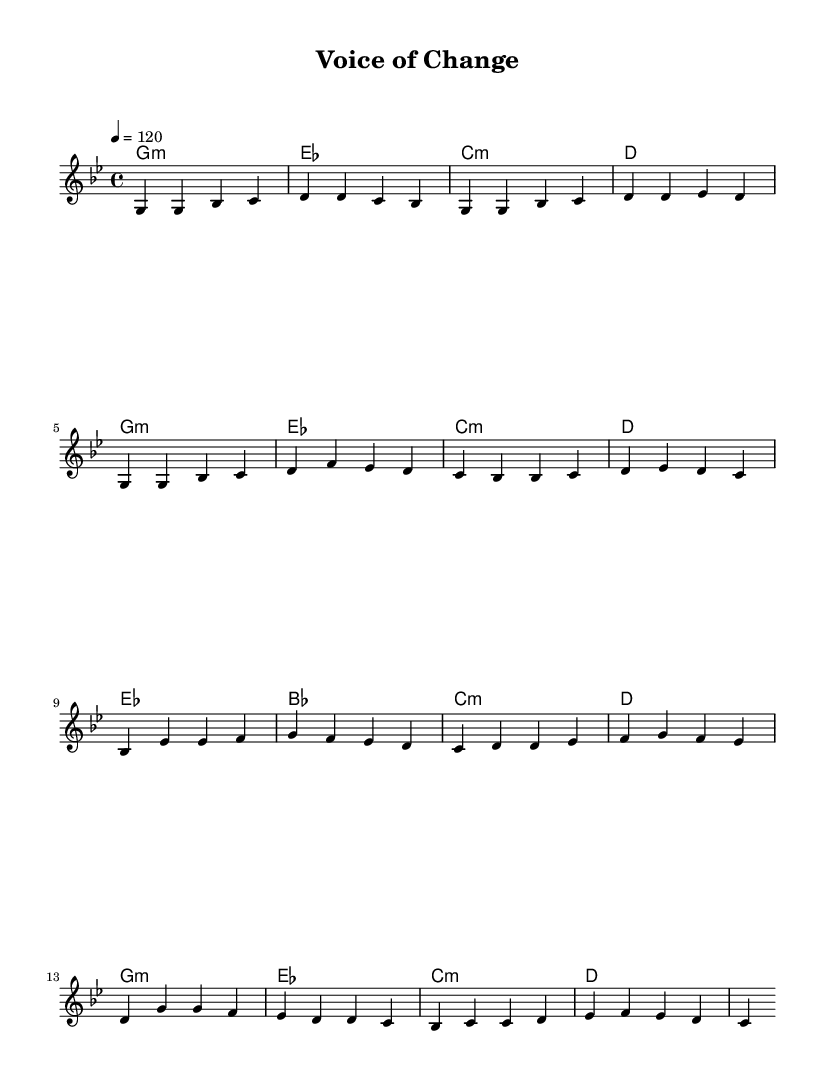What is the key signature of this music? The key signature is G minor, which is identified by two flat notes: B flat and E flat. This can be determined by observing the key signature at the beginning of the sheet music.
Answer: G minor What is the time signature of this music? The time signature is 4/4, which means there are four beats in each measure and that the quarter note gets the beat. This is indicated at the beginning of the score.
Answer: 4/4 What is the tempo marking of this music? The tempo marking is quarter note equals 120 beats per minute. This can be found in the tempo indication at the beginning of the sheet music.
Answer: 120 How many measures are in the chorus section? The chorus consists of four measures, which can be counted accurately by looking at the corresponding section in the sheet music and counting the separated vertical lines that indicate the end of each measure.
Answer: 4 What is the first chord of the piece? The first chord of the piece is G minor. This is indicated in the first measure under the chord names, where G minor is specified as the harmonic foundation of the melody.
Answer: G minor Which musical section uses B flat prominently? The pre-chorus section uses B flat prominently, as it is the first chord in that segment, appearing in the arrangement of chords beneath the melody.
Answer: Pre-Chorus What device is frequently used in K-Pop highlighted in this piece? The device frequently used is a catchy chorus. This can be identified by the repetitive nature of the melody and lyrics in the chorus section, which is a hallmark of K-Pop songs.
Answer: Catchy chorus 